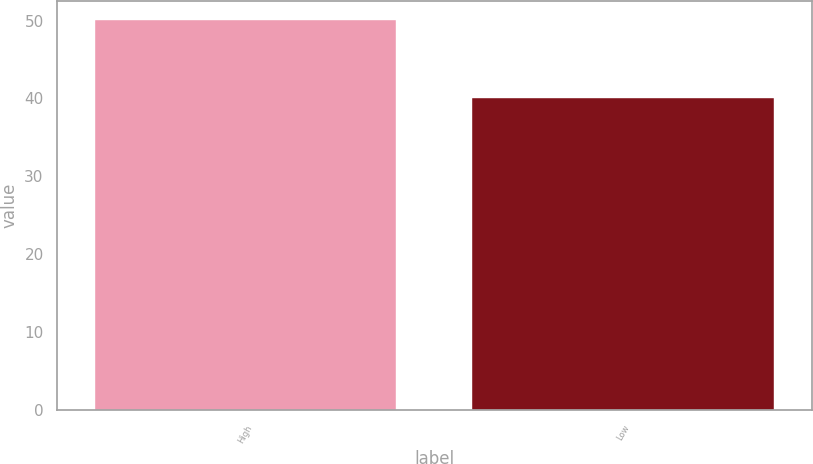Convert chart. <chart><loc_0><loc_0><loc_500><loc_500><bar_chart><fcel>High<fcel>Low<nl><fcel>50.05<fcel>40.12<nl></chart> 